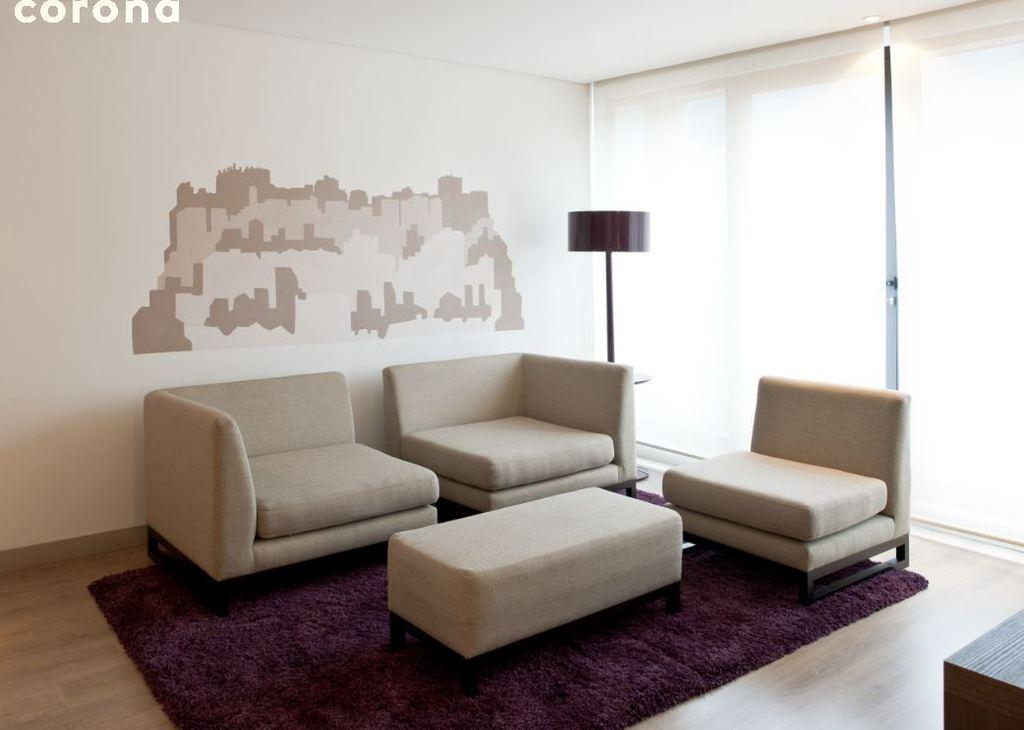What type of furniture is visible in the image? There are chairs and a table in the image. Where are the chairs and table located? The chairs and table are on the floor in the image. What other objects can be seen in the image? There is a lamp and glass windows in the image. How are the glass windows treated? The glass windows are covered with curtains in the image. How many cows are standing on the chairs in the image? There are no cows present in the image; it only features chairs, a table, a lamp, glass windows, and curtains. 